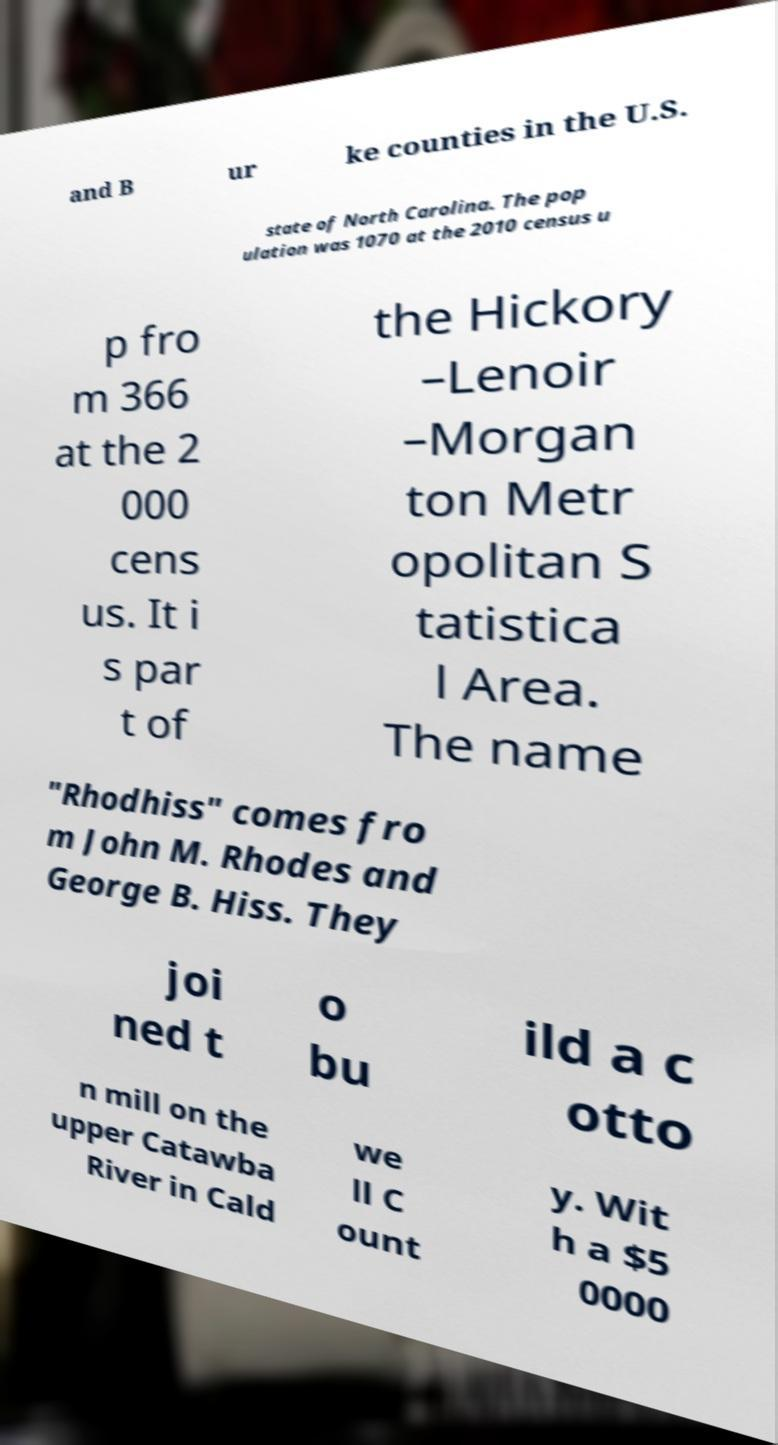Can you accurately transcribe the text from the provided image for me? and B ur ke counties in the U.S. state of North Carolina. The pop ulation was 1070 at the 2010 census u p fro m 366 at the 2 000 cens us. It i s par t of the Hickory –Lenoir –Morgan ton Metr opolitan S tatistica l Area. The name "Rhodhiss" comes fro m John M. Rhodes and George B. Hiss. They joi ned t o bu ild a c otto n mill on the upper Catawba River in Cald we ll C ount y. Wit h a $5 0000 